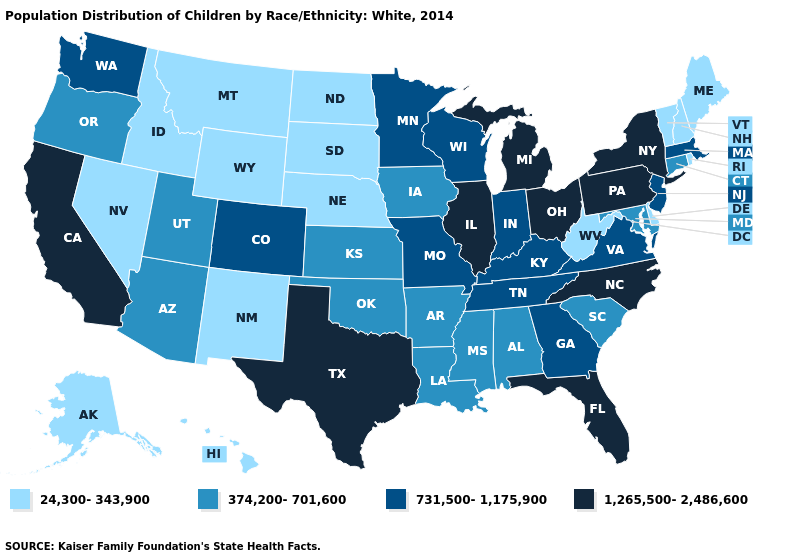Does Michigan have the highest value in the MidWest?
Write a very short answer. Yes. What is the lowest value in states that border Utah?
Answer briefly. 24,300-343,900. Does New York have the highest value in the USA?
Answer briefly. Yes. Name the states that have a value in the range 374,200-701,600?
Answer briefly. Alabama, Arizona, Arkansas, Connecticut, Iowa, Kansas, Louisiana, Maryland, Mississippi, Oklahoma, Oregon, South Carolina, Utah. Does New Hampshire have the lowest value in the USA?
Short answer required. Yes. Does the map have missing data?
Give a very brief answer. No. Name the states that have a value in the range 1,265,500-2,486,600?
Give a very brief answer. California, Florida, Illinois, Michigan, New York, North Carolina, Ohio, Pennsylvania, Texas. What is the value of Delaware?
Concise answer only. 24,300-343,900. What is the lowest value in states that border Kentucky?
Answer briefly. 24,300-343,900. What is the value of Colorado?
Give a very brief answer. 731,500-1,175,900. What is the highest value in the USA?
Short answer required. 1,265,500-2,486,600. What is the value of Washington?
Answer briefly. 731,500-1,175,900. Which states have the lowest value in the West?
Short answer required. Alaska, Hawaii, Idaho, Montana, Nevada, New Mexico, Wyoming. Which states hav the highest value in the West?
Answer briefly. California. Name the states that have a value in the range 731,500-1,175,900?
Give a very brief answer. Colorado, Georgia, Indiana, Kentucky, Massachusetts, Minnesota, Missouri, New Jersey, Tennessee, Virginia, Washington, Wisconsin. 